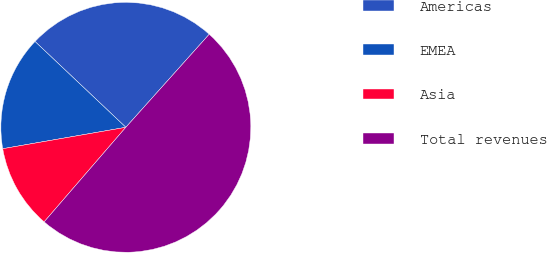<chart> <loc_0><loc_0><loc_500><loc_500><pie_chart><fcel>Americas<fcel>EMEA<fcel>Asia<fcel>Total revenues<nl><fcel>24.58%<fcel>14.79%<fcel>10.92%<fcel>49.71%<nl></chart> 